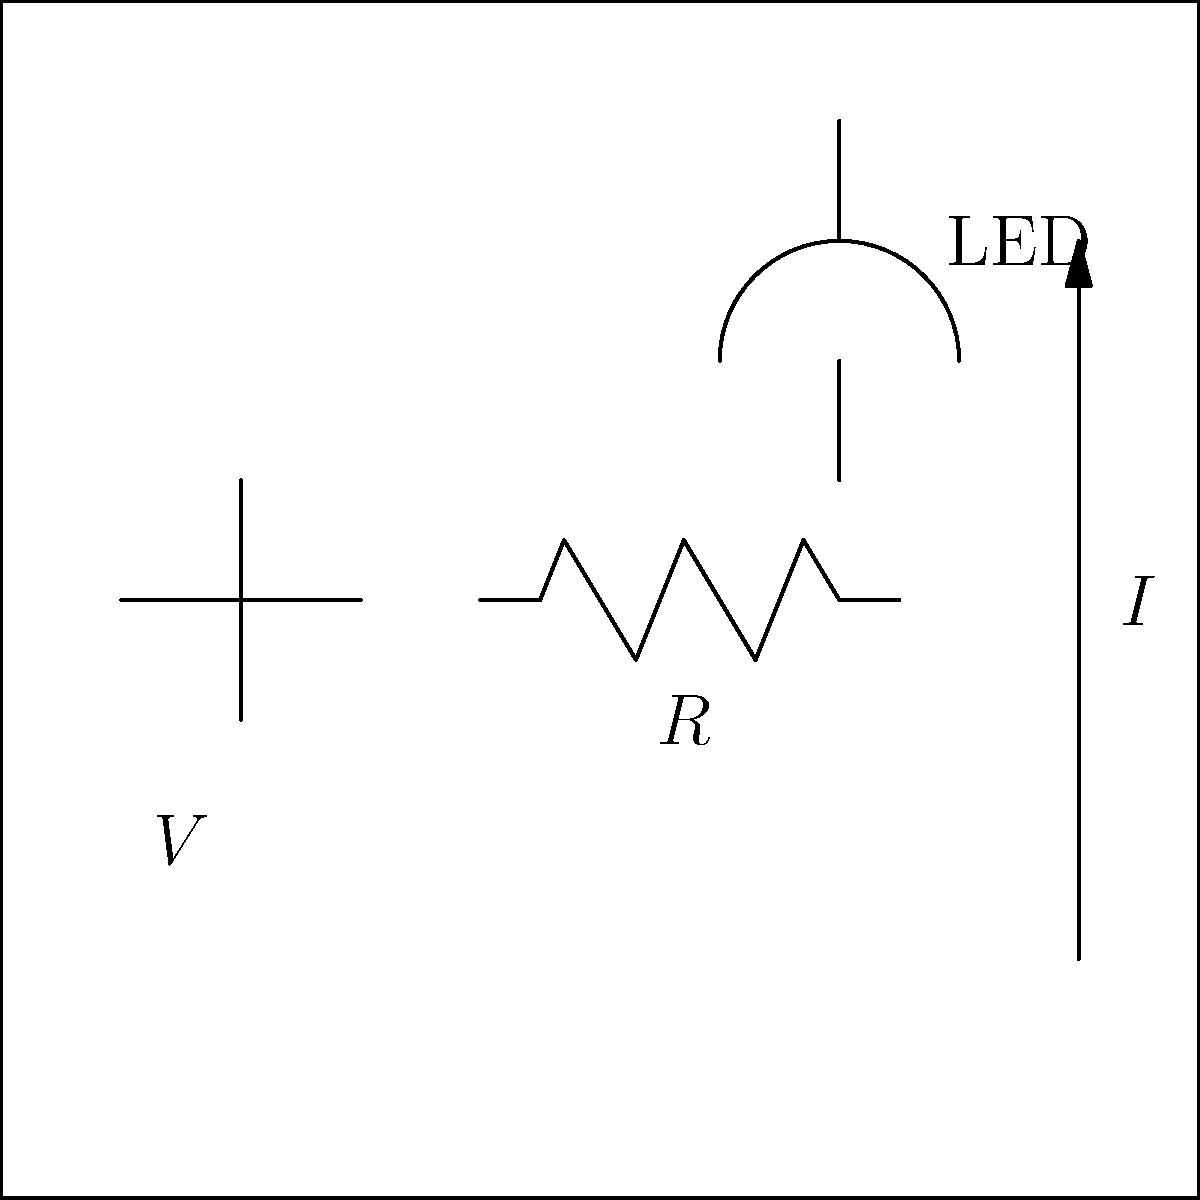In a circuit designed for a Pixar-style animated lamp, an LED is connected in series with a resistor to a voltage source. If the voltage source is 5V, the LED has a forward voltage of 2V, and the desired current through the LED is 20mA, what should be the resistance of the resistor? To determine the resistance needed in the circuit, we can follow these steps:

1) First, we need to find the voltage drop across the resistor. We know:
   - The total voltage of the source, $V_{source} = 5V$
   - The forward voltage of the LED, $V_{LED} = 2V$
   
   The voltage across the resistor will be:
   $V_R = V_{source} - V_{LED} = 5V - 2V = 3V$

2) We're given the desired current through the LED, which is also the current through the resistor:
   $I = 20mA = 0.02A$

3) Now we can use Ohm's Law to calculate the required resistance:
   $R = \frac{V_R}{I} = \frac{3V}{0.02A} = 150\Omega$

Therefore, to achieve the desired current of 20mA through the LED with a 5V source, we need a 150Ω resistor.
Answer: 150Ω 